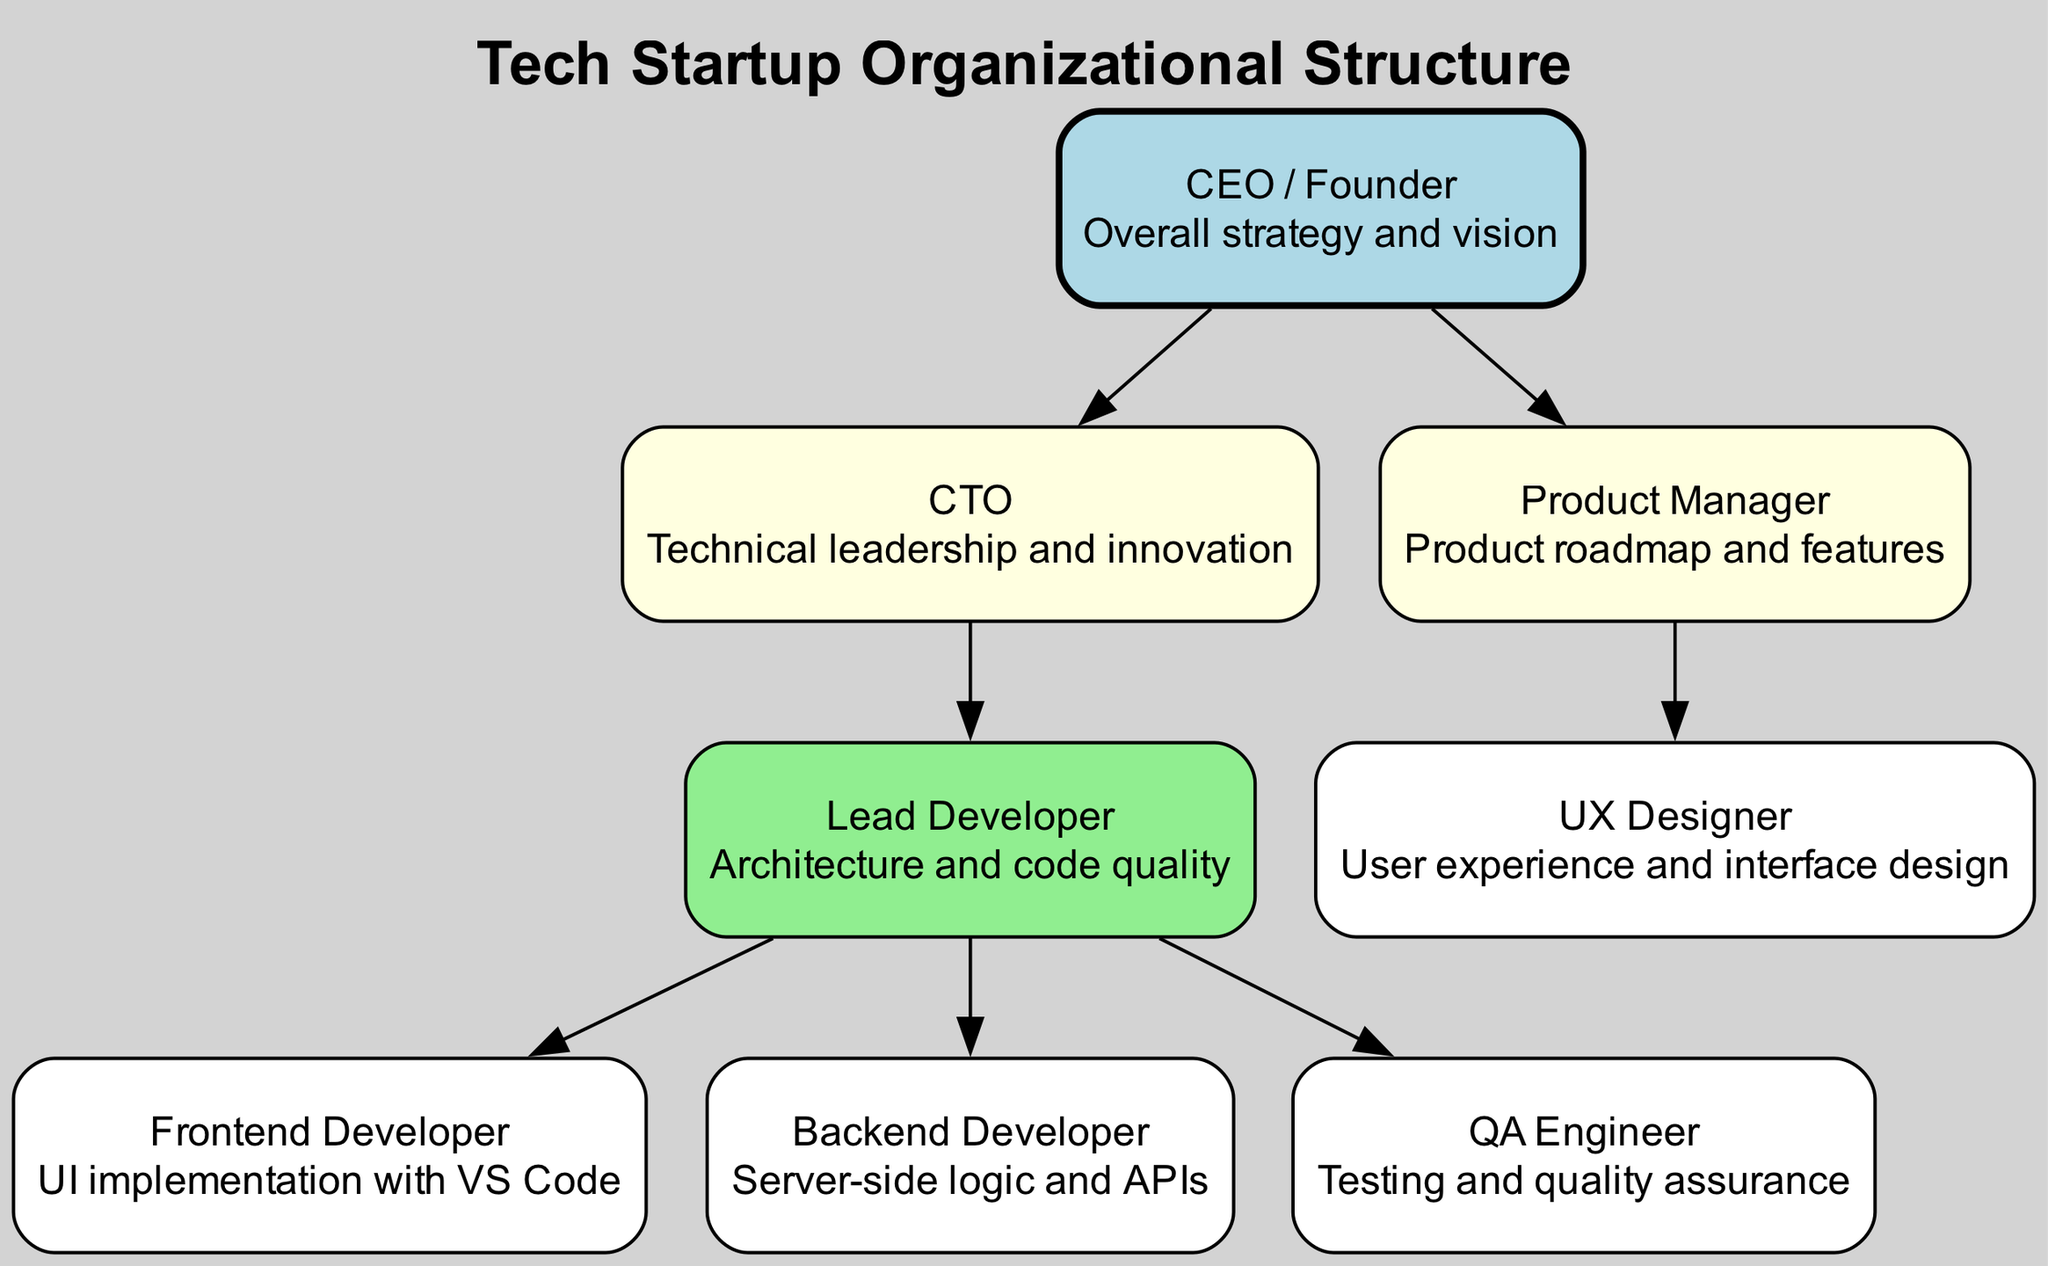What is the title of the diagram? The title is explicitly stated in the data as "Tech Startup Organizational Structure." It is also presented at the top of the diagram as a title label.
Answer: Tech Startup Organizational Structure How many key roles are depicted in the diagram? Counting the nodes in the diagram indicates there are eight key roles represented: CEO, CTO, Product Manager, Lead Developer, UX Designer, Frontend Developer, Backend Developer, and QA Engineer. Each role corresponds to a unique node.
Answer: 8 What color represents the CEO node? The color assigned to the CEO node is described in the node attributes as "lightblue." The specific attributes for the CEO in the code set this unique color distinctively.
Answer: lightblue Which role reports directly to the CEO? The diagram shows that the CTO and Product Manager report directly to the CEO. By tracing the arrows (edges) from the CEO node, we can observe these direct connections.
Answer: CTO, Product Manager What is the primary responsibility of the CTO? The description associated with the CTO node states, "Technical leadership and innovation." This is the specific responsibility detailed for the CTO role in the diagram.
Answer: Technical leadership and innovation Which roles report to the Lead Developer? Inspecting the edges originating from the Lead Developer node reveals connections to Frontend Developer, Backend Developer, and QA Engineer nodes, indicating that these roles directly report to the Lead Developer.
Answer: Frontend Developer, Backend Developer, QA Engineer How does the Product Manager connect to the UX Designer? The connection between the Product Manager and UX Designer can be traced using the edge defined in the diagram's edges, where the Product Manager node has an arrow leading to the UX Designer node, indicating this reporting relationship.
Answer: Direct report What is the hierarchical level of the UX Designer in relation to the CEO? The UX Designer is positioned three levels below the CEO in the hierarchy indicated by the edges connecting CEO to ProductManager, then to UXDesigner. By following the paths, we see the UX Designer's placement within the organizational structure.
Answer: Level 3 How many reporting relationships are there in total? The number of edges in the diagram determines the count of reporting relationships. There are seven edges connecting the different nodes, reflecting the total number of reporting relationships captured in the diagram.
Answer: 7 